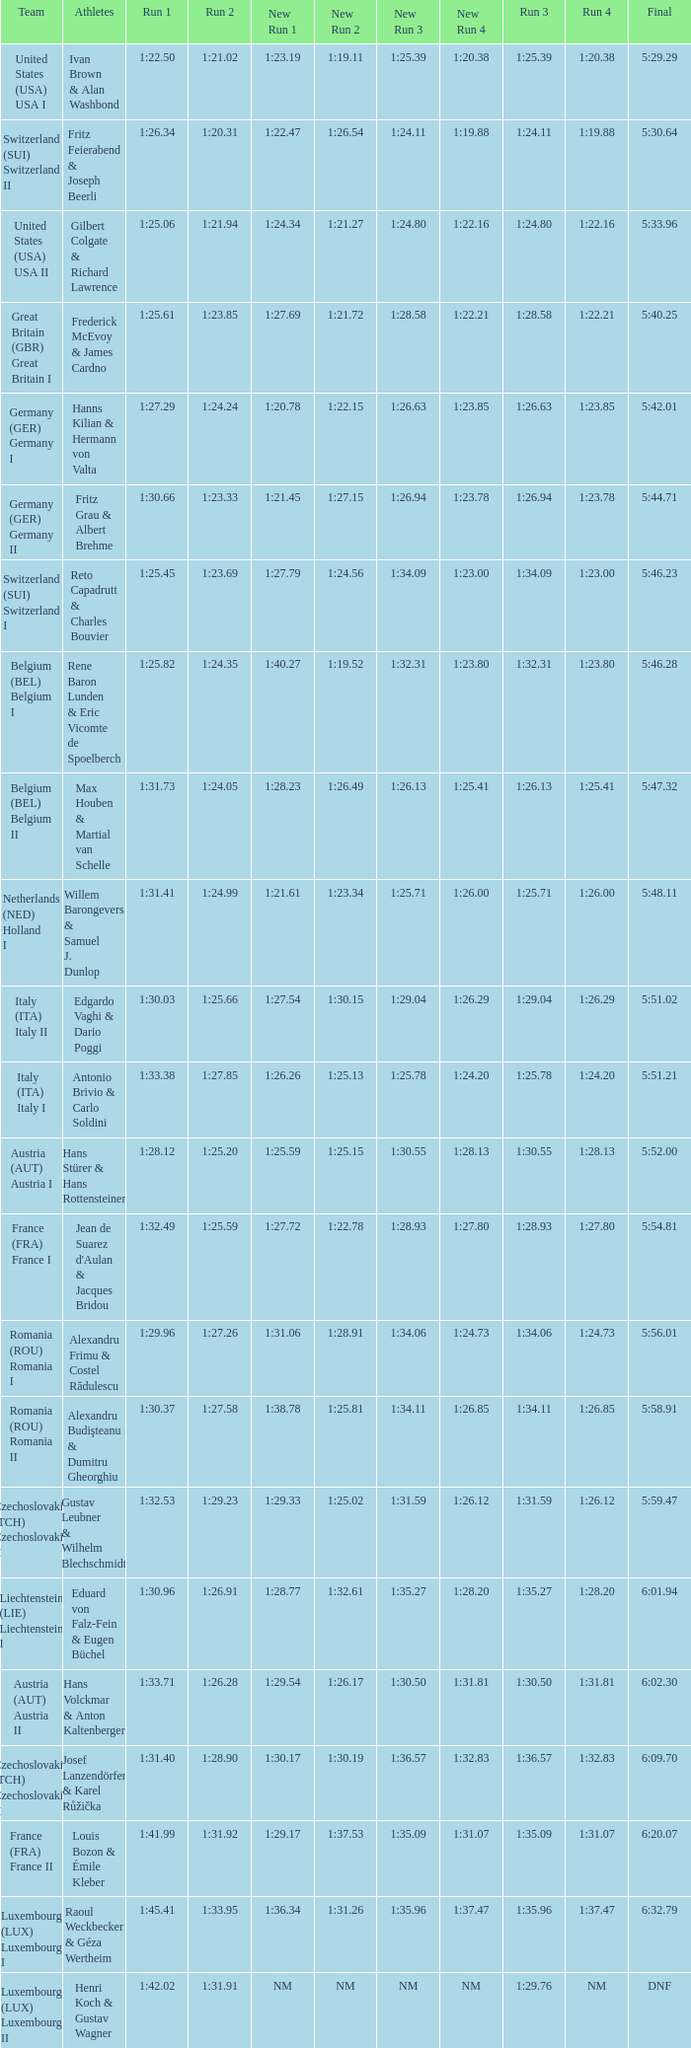Which Final has a Team of liechtenstein (lie) liechtenstein i? 6:01.94. 